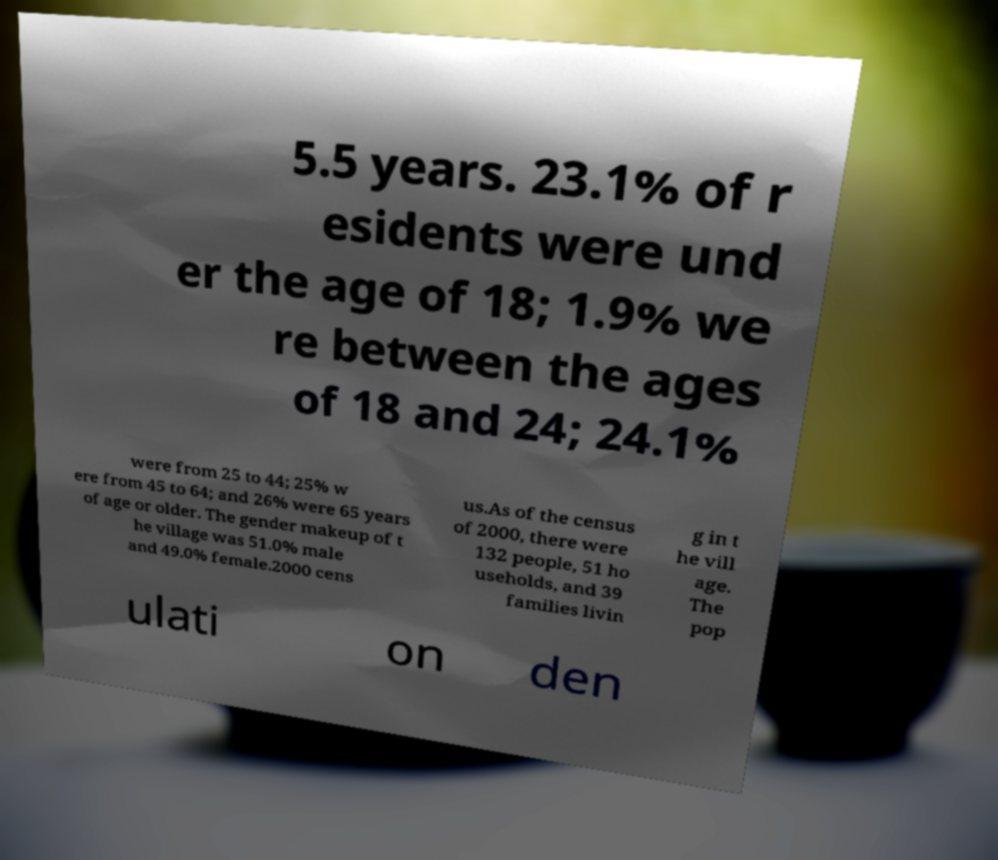Can you read and provide the text displayed in the image?This photo seems to have some interesting text. Can you extract and type it out for me? 5.5 years. 23.1% of r esidents were und er the age of 18; 1.9% we re between the ages of 18 and 24; 24.1% were from 25 to 44; 25% w ere from 45 to 64; and 26% were 65 years of age or older. The gender makeup of t he village was 51.0% male and 49.0% female.2000 cens us.As of the census of 2000, there were 132 people, 51 ho useholds, and 39 families livin g in t he vill age. The pop ulati on den 